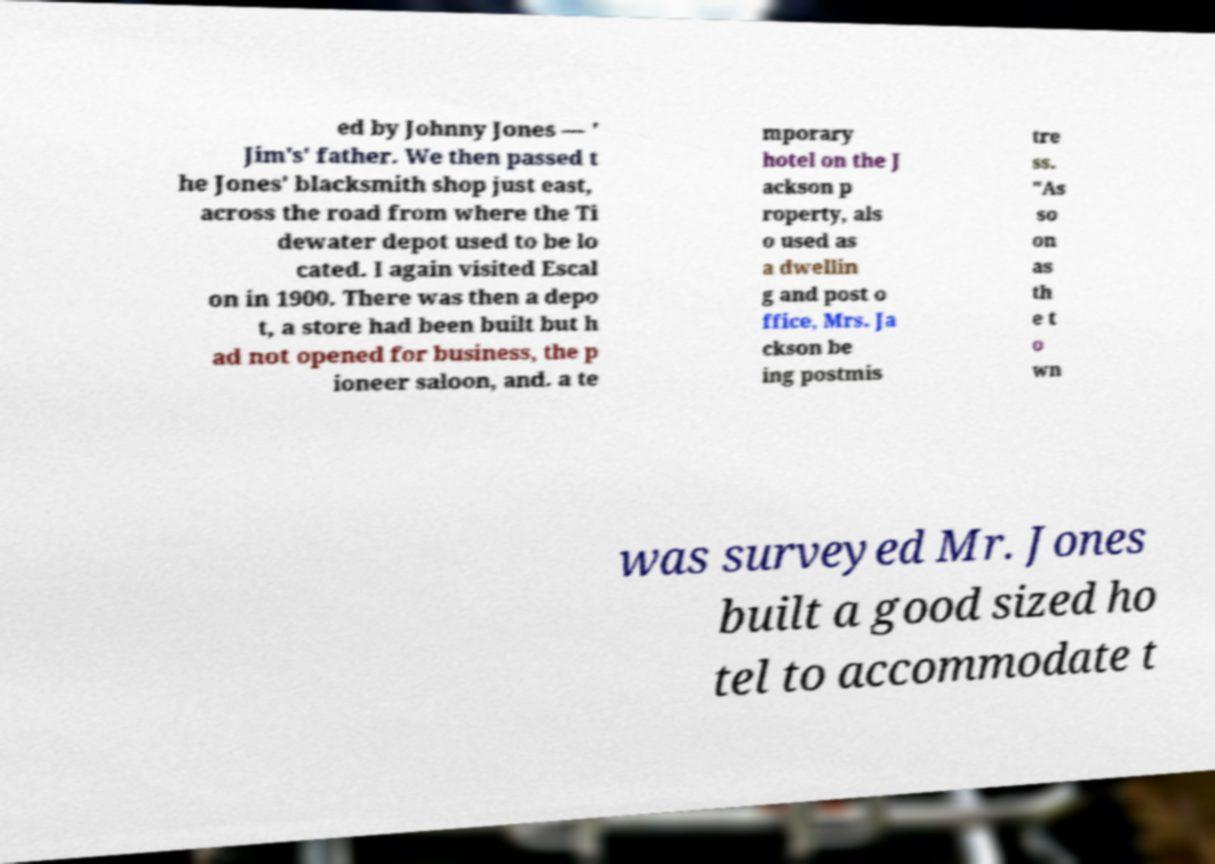I need the written content from this picture converted into text. Can you do that? ed by Johnny Jones — ' Jim's' father. We then passed t he Jones' blacksmith shop just east, across the road from where the Ti dewater depot used to be lo cated. I again visited Escal on in 1900. There was then a depo t, a store had been built but h ad not opened for business, the p ioneer saloon, and. a te mporary hotel on the J ackson p roperty, als o used as a dwellin g and post o ffice, Mrs. Ja ckson be ing postmis tre ss. "As so on as th e t o wn was surveyed Mr. Jones built a good sized ho tel to accommodate t 